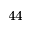<formula> <loc_0><loc_0><loc_500><loc_500>_ { 4 4 }</formula> 